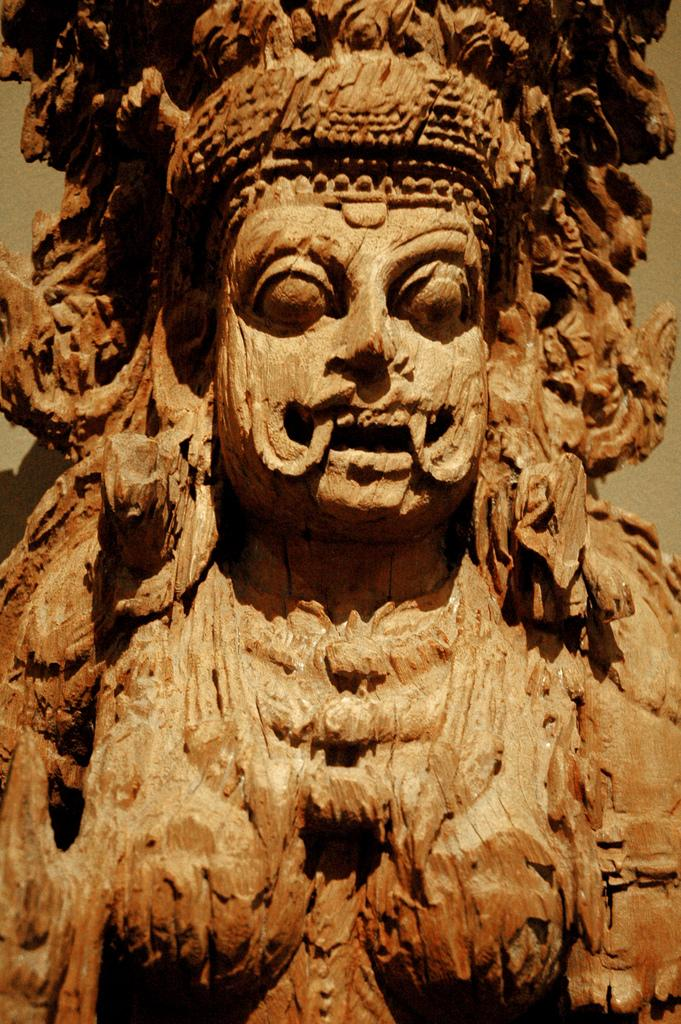What is the main subject of the image? The main subject of the image is a picture of a statue. What type of pear is being used as a prop in the statue's hand in the image? There is no pear present in the image; the statue is not holding any fruit or object. 